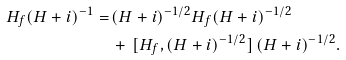<formula> <loc_0><loc_0><loc_500><loc_500>H _ { f } ( H + i ) ^ { - 1 } = \, & ( H + i ) ^ { - 1 / 2 } H _ { f } ( H + i ) ^ { - 1 / 2 } \\ & + \, [ H _ { f } , ( H + i ) ^ { - 1 / 2 } ] \, ( H + i ) ^ { - 1 / 2 } .</formula> 